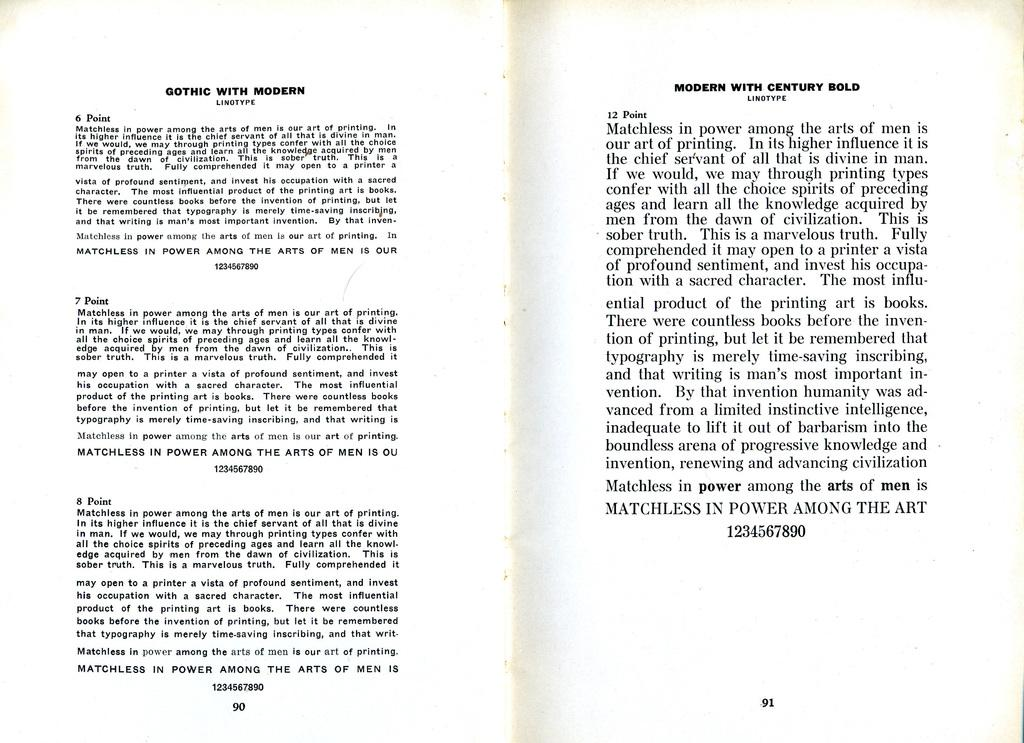<image>
Render a clear and concise summary of the photo. Samples are provided of various linotypes including Gothic with Modern and Modern with Century Bold. 